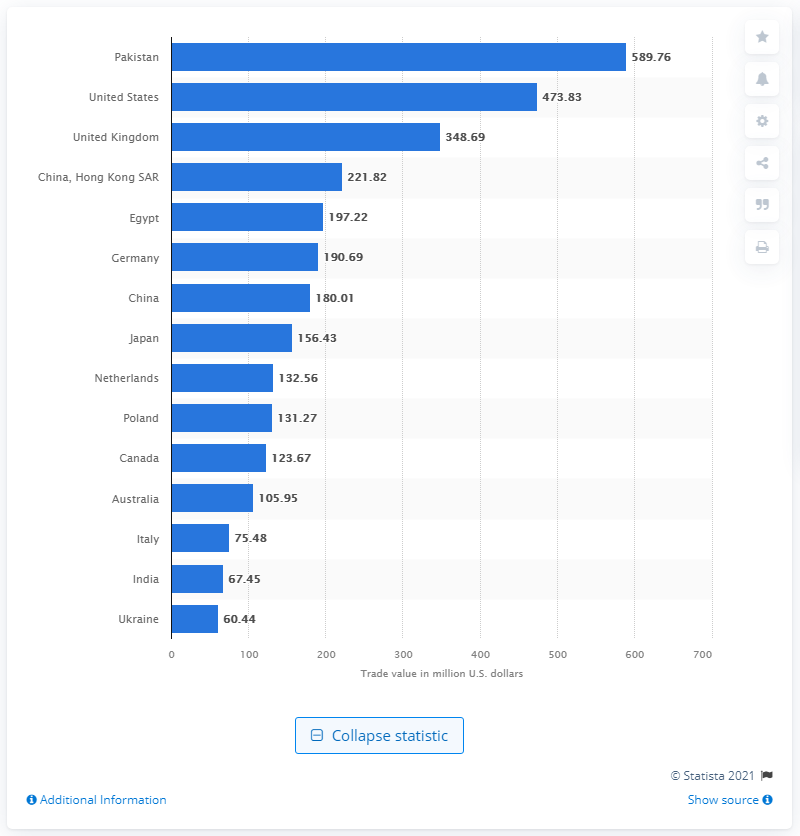How does the tea import value of China compare to that of India? In the image, China's import value for tea in 2020 stands at about 180 million U.S. dollars, while India, known for being a significant tea producer itself, has a comparatively lower import value of roughly 67 million U.S. dollars. What trend can we infer about tea importing based on this chart? The bar chart suggests that tea importation isn't dominated by traditionally tea-producing countries. Instead, major economic powers like the U.S., European countries, and non-producing nations hold significant shares in tea imports, reflecting their substantial consumer markets for the beverage. 